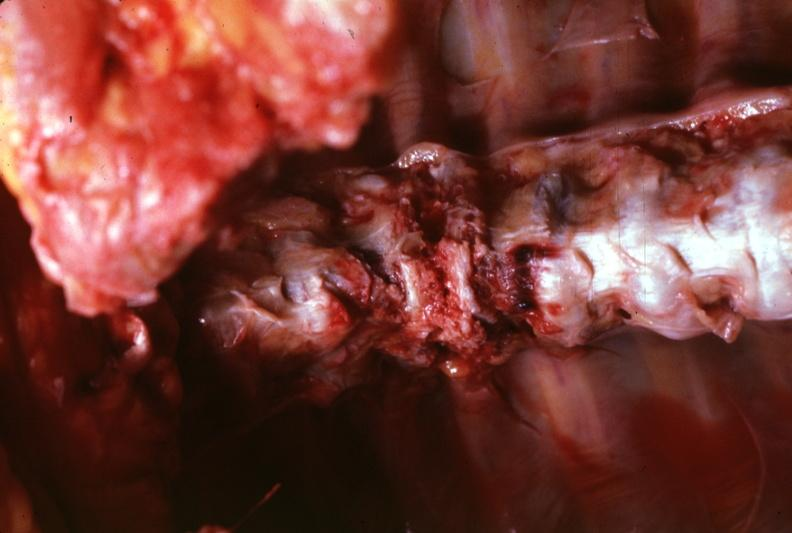what is present?
Answer the question using a single word or phrase. Joints 